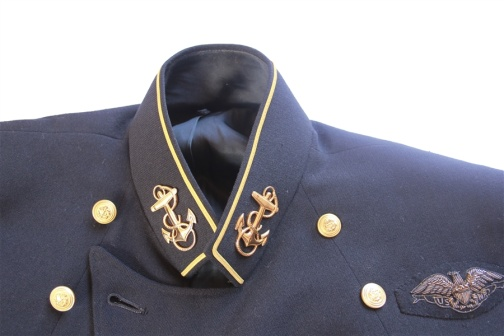What historical era might this military jacket belong to? The military jacket appears to be reminiscent of early to mid-20th century designs, possibly from the World War II era. The use of classical symbols and the style of the adornments suggest it could belong to a naval officer's uniform from this period. The choice of materials and design indicates a time when uniforms were crafted with considerable attention to detail and were intended to reflect the status and importance of the wearer. Can you provide more insight into the significance of the embroidered insignias on the collar? Certainly! The embroidered insignias on the collar appear to be anchors, which are a traditional maritime symbol. In military custom, anchors often denote a naval rank and are associated with maritime duty and authority. The gold stitching emphasizes their importance, signifying the wearer's connection to the naval branch of the military, and possibly their rank within it. Such insignias are not just decorative; they convey crucial information about the wearer's status, service, and affiliation. 